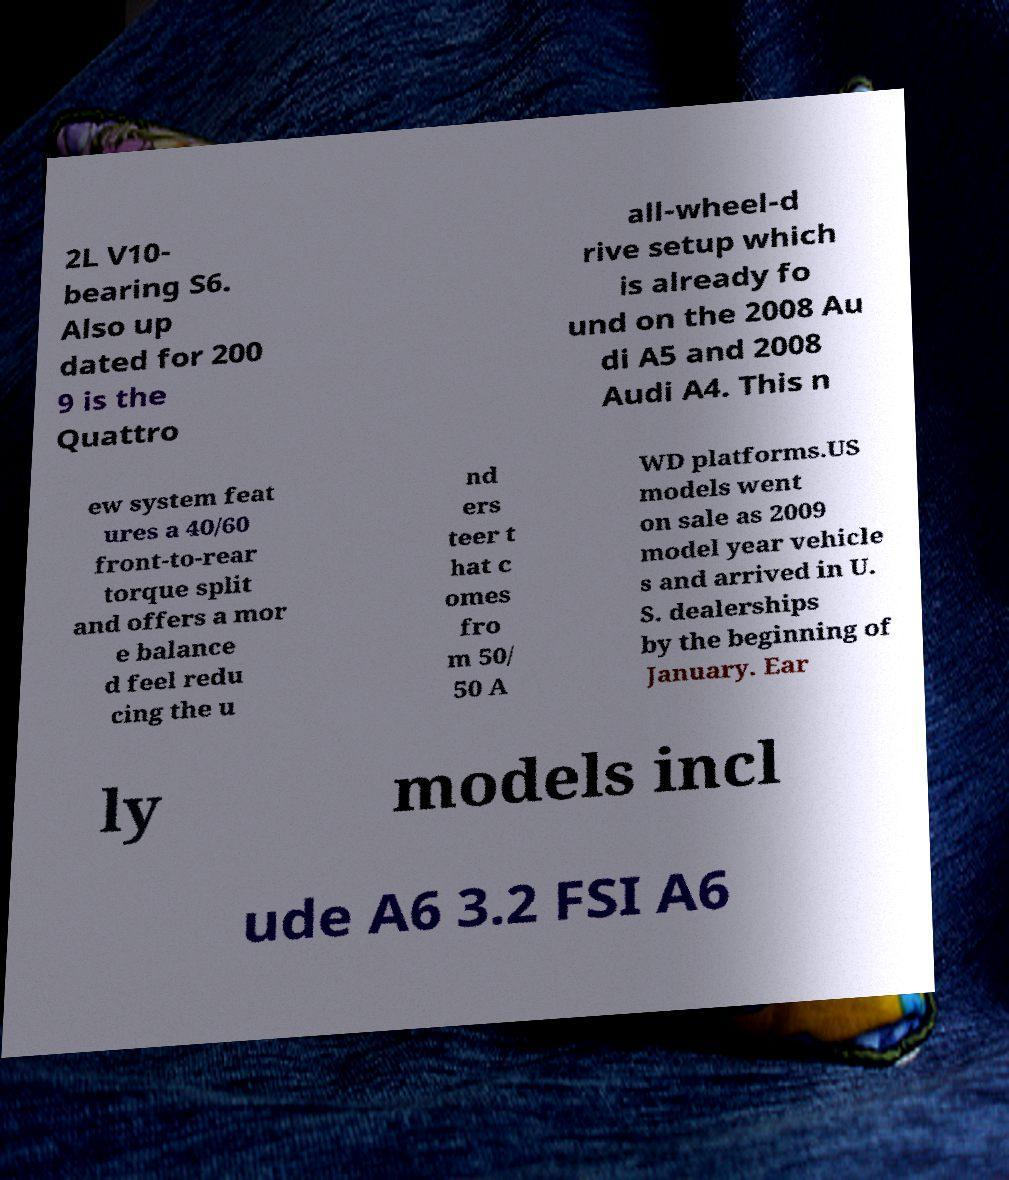For documentation purposes, I need the text within this image transcribed. Could you provide that? 2L V10- bearing S6. Also up dated for 200 9 is the Quattro all-wheel-d rive setup which is already fo und on the 2008 Au di A5 and 2008 Audi A4. This n ew system feat ures a 40/60 front-to-rear torque split and offers a mor e balance d feel redu cing the u nd ers teer t hat c omes fro m 50/ 50 A WD platforms.US models went on sale as 2009 model year vehicle s and arrived in U. S. dealerships by the beginning of January. Ear ly models incl ude A6 3.2 FSI A6 